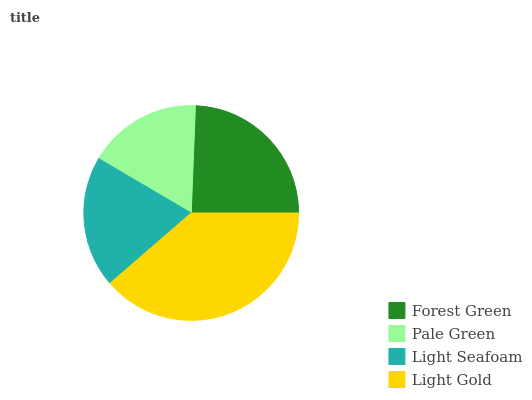Is Pale Green the minimum?
Answer yes or no. Yes. Is Light Gold the maximum?
Answer yes or no. Yes. Is Light Seafoam the minimum?
Answer yes or no. No. Is Light Seafoam the maximum?
Answer yes or no. No. Is Light Seafoam greater than Pale Green?
Answer yes or no. Yes. Is Pale Green less than Light Seafoam?
Answer yes or no. Yes. Is Pale Green greater than Light Seafoam?
Answer yes or no. No. Is Light Seafoam less than Pale Green?
Answer yes or no. No. Is Forest Green the high median?
Answer yes or no. Yes. Is Light Seafoam the low median?
Answer yes or no. Yes. Is Light Seafoam the high median?
Answer yes or no. No. Is Pale Green the low median?
Answer yes or no. No. 